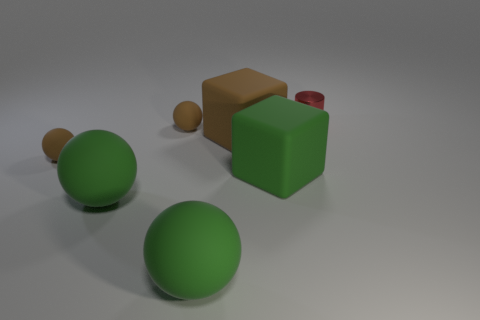Is there any other thing that has the same shape as the metallic thing?
Your response must be concise. No. Are there more large green rubber objects behind the small red metal thing than large green blocks to the left of the big green rubber block?
Make the answer very short. No. What shape is the large brown object that is made of the same material as the green block?
Ensure brevity in your answer.  Cube. Is the number of big rubber things that are to the left of the big brown rubber cube greater than the number of cyan objects?
Make the answer very short. Yes. Is the number of small cylinders greater than the number of brown rubber balls?
Ensure brevity in your answer.  No. What is the material of the small red thing?
Provide a succinct answer. Metal. There is a green thing to the right of the brown rubber block; does it have the same size as the brown matte cube?
Your response must be concise. Yes. There is a matte object behind the large brown rubber block; what size is it?
Make the answer very short. Small. Is there anything else that has the same material as the red thing?
Your answer should be compact. No. How many brown matte spheres are there?
Make the answer very short. 2. 